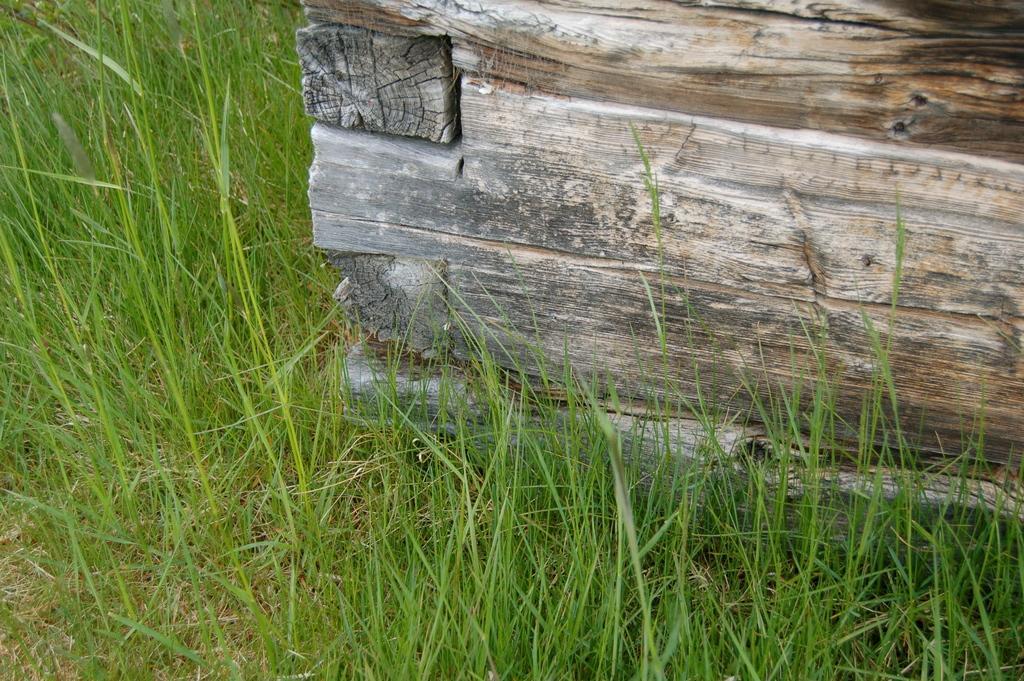Please provide a concise description of this image. In this picture we can see a wooden object and grass on the ground. 